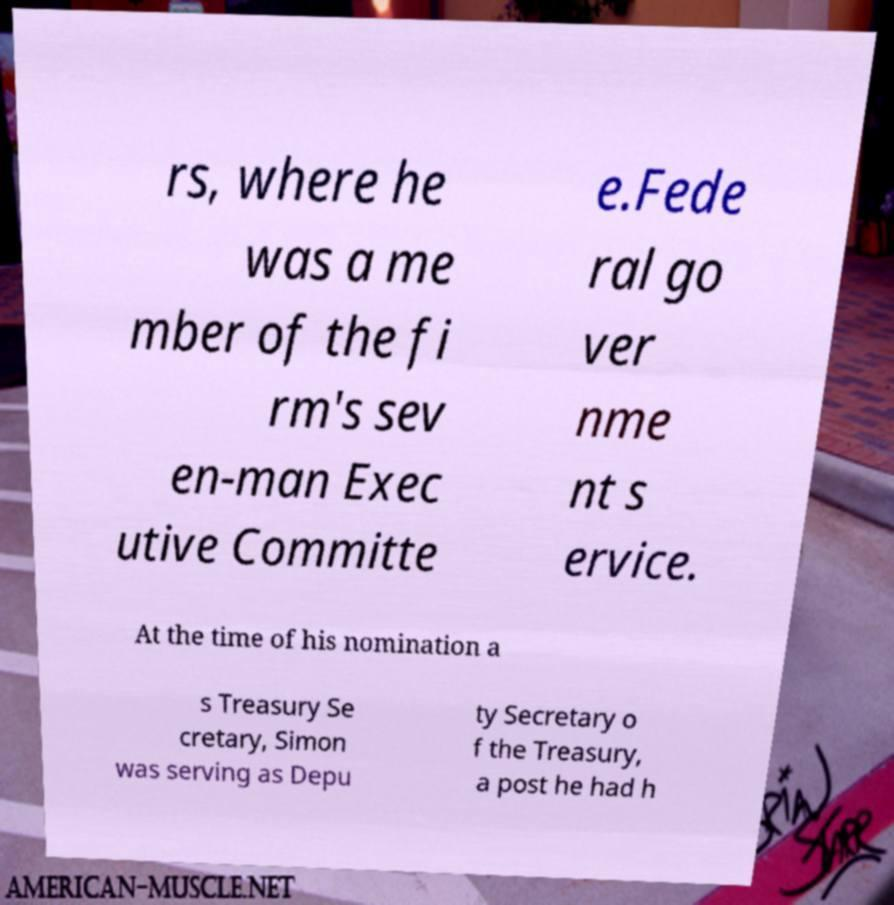What messages or text are displayed in this image? I need them in a readable, typed format. rs, where he was a me mber of the fi rm's sev en-man Exec utive Committe e.Fede ral go ver nme nt s ervice. At the time of his nomination a s Treasury Se cretary, Simon was serving as Depu ty Secretary o f the Treasury, a post he had h 